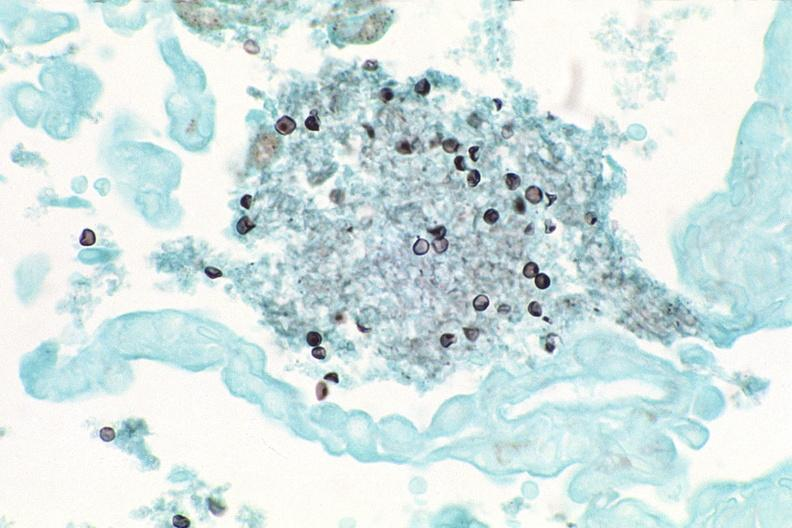does chromophobe adenoma show lung, pneumocystis pneumonia?
Answer the question using a single word or phrase. No 